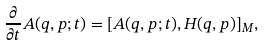Convert formula to latex. <formula><loc_0><loc_0><loc_500><loc_500>\frac { \partial } { \partial t } A ( q , p ; t ) = [ A ( q , p ; t ) , H ( q , p ) ] _ { M } ,</formula> 